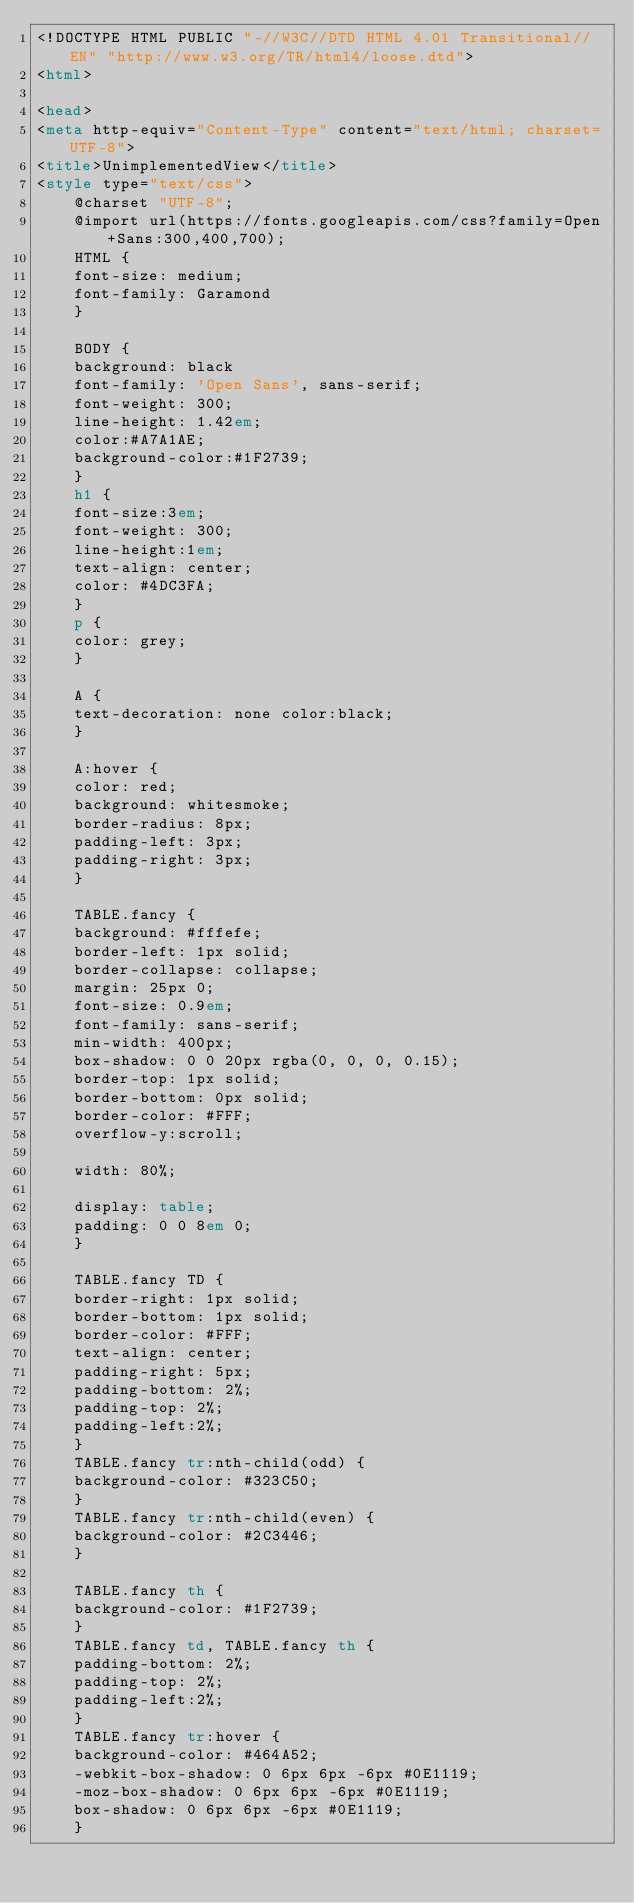Convert code to text. <code><loc_0><loc_0><loc_500><loc_500><_HTML_><!DOCTYPE HTML PUBLIC "-//W3C//DTD HTML 4.01 Transitional//EN" "http://www.w3.org/TR/html4/loose.dtd">
<html>

<head>
<meta http-equiv="Content-Type" content="text/html; charset=UTF-8">
<title>UnimplementedView</title>
<style type="text/css">
    @charset "UTF-8";
    @import url(https://fonts.googleapis.com/css?family=Open+Sans:300,400,700);
    HTML {
    font-size: medium;
    font-family: Garamond
    }

    BODY {
    background: black
    font-family: 'Open Sans', sans-serif;
    font-weight: 300;
    line-height: 1.42em;
    color:#A7A1AE;
    background-color:#1F2739;
    }
    h1 {
    font-size:3em;
    font-weight: 300;
    line-height:1em;
    text-align: center;
    color: #4DC3FA;
    }
    p {
    color: grey;
    }

    A {
    text-decoration: none color:black;
    }

    A:hover {
    color: red;
    background: whitesmoke;
    border-radius: 8px;
    padding-left: 3px;
    padding-right: 3px;
    }

    TABLE.fancy {
    background: #fffefe;
    border-left: 1px solid;
    border-collapse: collapse;
    margin: 25px 0;
    font-size: 0.9em;
    font-family: sans-serif;
    min-width: 400px;
    box-shadow: 0 0 20px rgba(0, 0, 0, 0.15);
    border-top: 1px solid;
    border-bottom: 0px solid;
    border-color: #FFF;
    overflow-y:scroll;

    width: 80%;

    display: table;
    padding: 0 0 8em 0;
    }

    TABLE.fancy TD {
    border-right: 1px solid;
    border-bottom: 1px solid;
    border-color: #FFF;
    text-align: center;
    padding-right: 5px;
    padding-bottom: 2%;
    padding-top: 2%;
    padding-left:2%;
    }
    TABLE.fancy tr:nth-child(odd) {
    background-color: #323C50;
    }
    TABLE.fancy tr:nth-child(even) {
    background-color: #2C3446;
    }

    TABLE.fancy th {
    background-color: #1F2739;
    }
    TABLE.fancy td, TABLE.fancy th {
    padding-bottom: 2%;
    padding-top: 2%;
    padding-left:2%;
    }
    TABLE.fancy tr:hover {
    background-color: #464A52;
    -webkit-box-shadow: 0 6px 6px -6px #0E1119;
    -moz-box-shadow: 0 6px 6px -6px #0E1119;
    box-shadow: 0 6px 6px -6px #0E1119;
    }</code> 